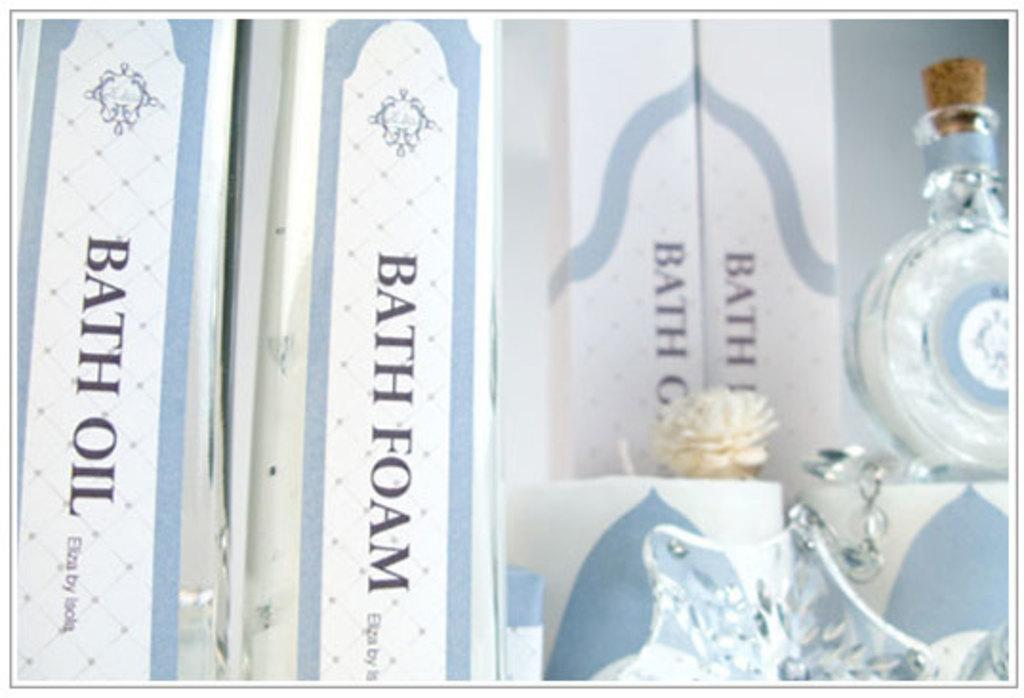<image>
Write a terse but informative summary of the picture. Several boxes of bath foam are sitting with a bottle near by. 